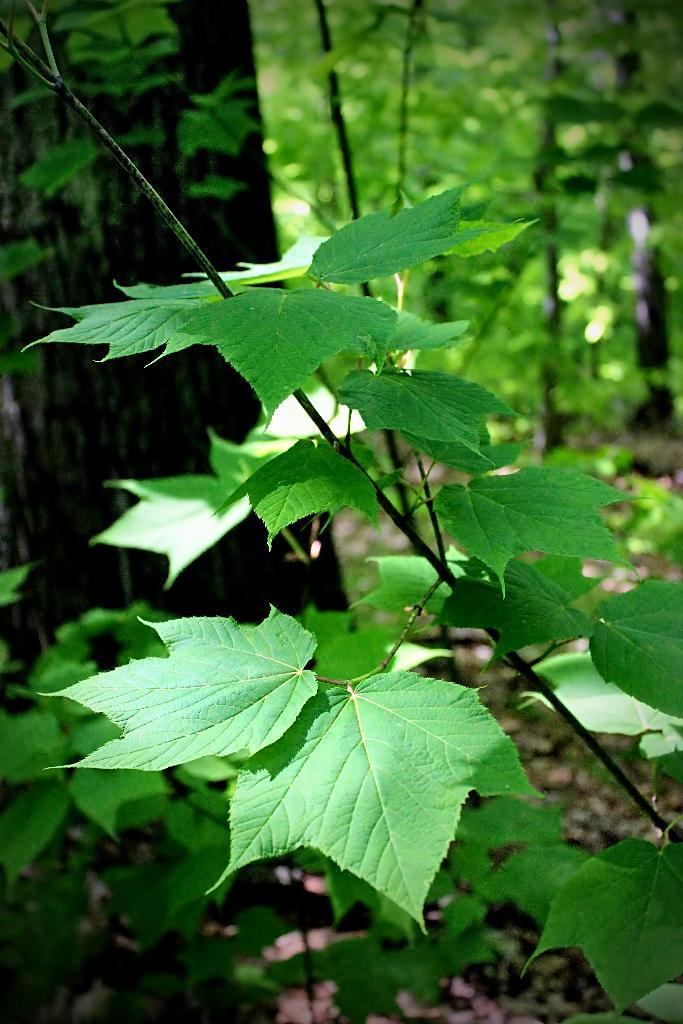What type of vegetation is in the foreground of the image? There are plants in the foreground of the image. What type of vegetation is in the background of the image? There are trees in the background of the image. What type of ground cover is visible at the bottom of the image? There is grass at the bottom of the image. What additional feature can be seen at the bottom of the image? Dry leaves are present at the bottom of the image. What type of honey can be seen dripping from the leaves in the image? There is no honey present in the image; it features plants, trees, grass, and dry leaves. What advice might the father in the image give about the plants? There is no father present in the image, so it is not possible to determine what advice he might give. 